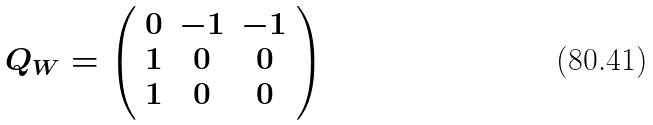Convert formula to latex. <formula><loc_0><loc_0><loc_500><loc_500>Q _ { W } = \left ( \begin{array} { c c c } 0 & - 1 & - 1 \\ 1 & 0 & 0 \\ 1 & 0 & 0 \end{array} \right ) \</formula> 